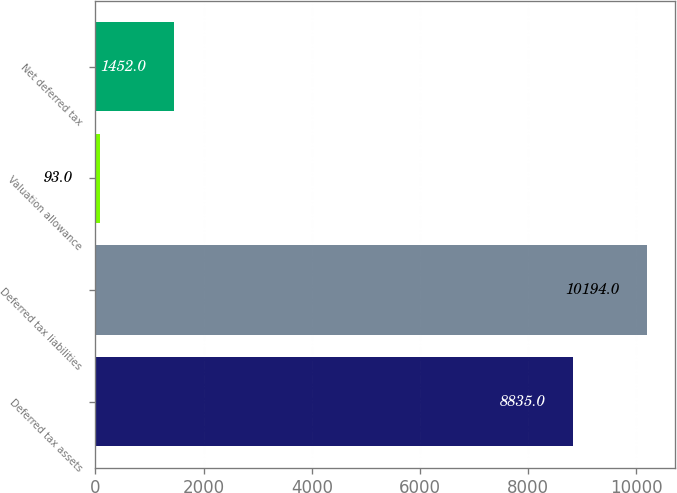Convert chart. <chart><loc_0><loc_0><loc_500><loc_500><bar_chart><fcel>Deferred tax assets<fcel>Deferred tax liabilities<fcel>Valuation allowance<fcel>Net deferred tax<nl><fcel>8835<fcel>10194<fcel>93<fcel>1452<nl></chart> 